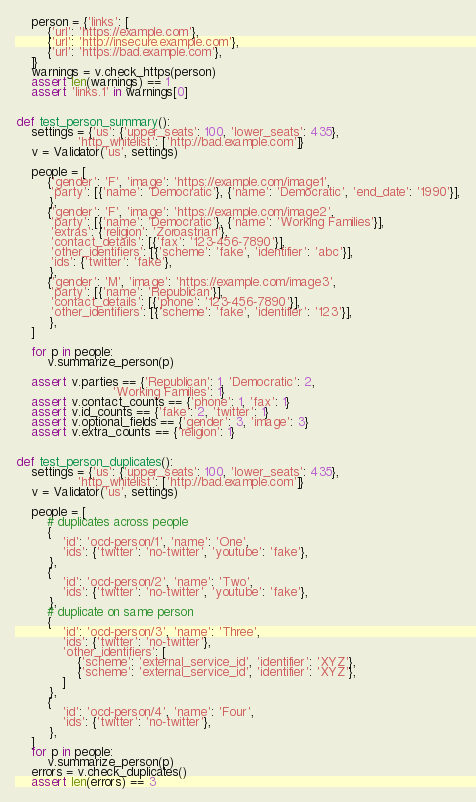<code> <loc_0><loc_0><loc_500><loc_500><_Python_>    person = {'links': [
        {'url': 'https://example.com'},
        {'url': 'http://insecure.example.com'},
        {'url': 'https://bad.example.com'},
    ]}
    warnings = v.check_https(person)
    assert len(warnings) == 1
    assert 'links.1' in warnings[0]


def test_person_summary():
    settings = {'us': {'upper_seats': 100, 'lower_seats': 435},
                'http_whitelist': ['http://bad.example.com']}
    v = Validator('us', settings)

    people = [
        {'gender': 'F', 'image': 'https://example.com/image1',
         'party': [{'name': 'Democratic'}, {'name': 'Democratic', 'end_date': '1990'}],
         },
        {'gender': 'F', 'image': 'https://example.com/image2',
         'party': [{'name': 'Democratic'}, {'name': 'Working Families'}],
         'extras': {'religion': 'Zoroastrian'},
         'contact_details': [{'fax': '123-456-7890'}],
         'other_identifiers': [{'scheme': 'fake', 'identifier': 'abc'}],
         'ids': {'twitter': 'fake'},
         },
        {'gender': 'M', 'image': 'https://example.com/image3',
         'party': [{'name': 'Republican'}],
         'contact_details': [{'phone': '123-456-7890'}],
         'other_identifiers': [{'scheme': 'fake', 'identifier': '123'}],
         },
    ]

    for p in people:
        v.summarize_person(p)

    assert v.parties == {'Republican': 1, 'Democratic': 2,
                         'Working Families': 1}
    assert v.contact_counts == {'phone': 1, 'fax': 1}
    assert v.id_counts == {'fake': 2, 'twitter': 1}
    assert v.optional_fields == {'gender': 3, 'image': 3}
    assert v.extra_counts == {'religion': 1}


def test_person_duplicates():
    settings = {'us': {'upper_seats': 100, 'lower_seats': 435},
                'http_whitelist': ['http://bad.example.com']}
    v = Validator('us', settings)

    people = [
        # duplicates across people
        {
            'id': 'ocd-person/1', 'name': 'One',
            'ids': {'twitter': 'no-twitter', 'youtube': 'fake'},
         },
        {
            'id': 'ocd-person/2', 'name': 'Two',
            'ids': {'twitter': 'no-twitter', 'youtube': 'fake'},
         },
        # duplicate on same person
        {
            'id': 'ocd-person/3', 'name': 'Three',
            'ids': {'twitter': 'no-twitter'},
            'other_identifiers': [
                {'scheme': 'external_service_id', 'identifier': 'XYZ'},
                {'scheme': 'external_service_id', 'identifier': 'XYZ'},
            ]
         },
        {
            'id': 'ocd-person/4', 'name': 'Four',
            'ids': {'twitter': 'no-twitter'},
         },
    ]
    for p in people:
        v.summarize_person(p)
    errors = v.check_duplicates()
    assert len(errors) == 3</code> 